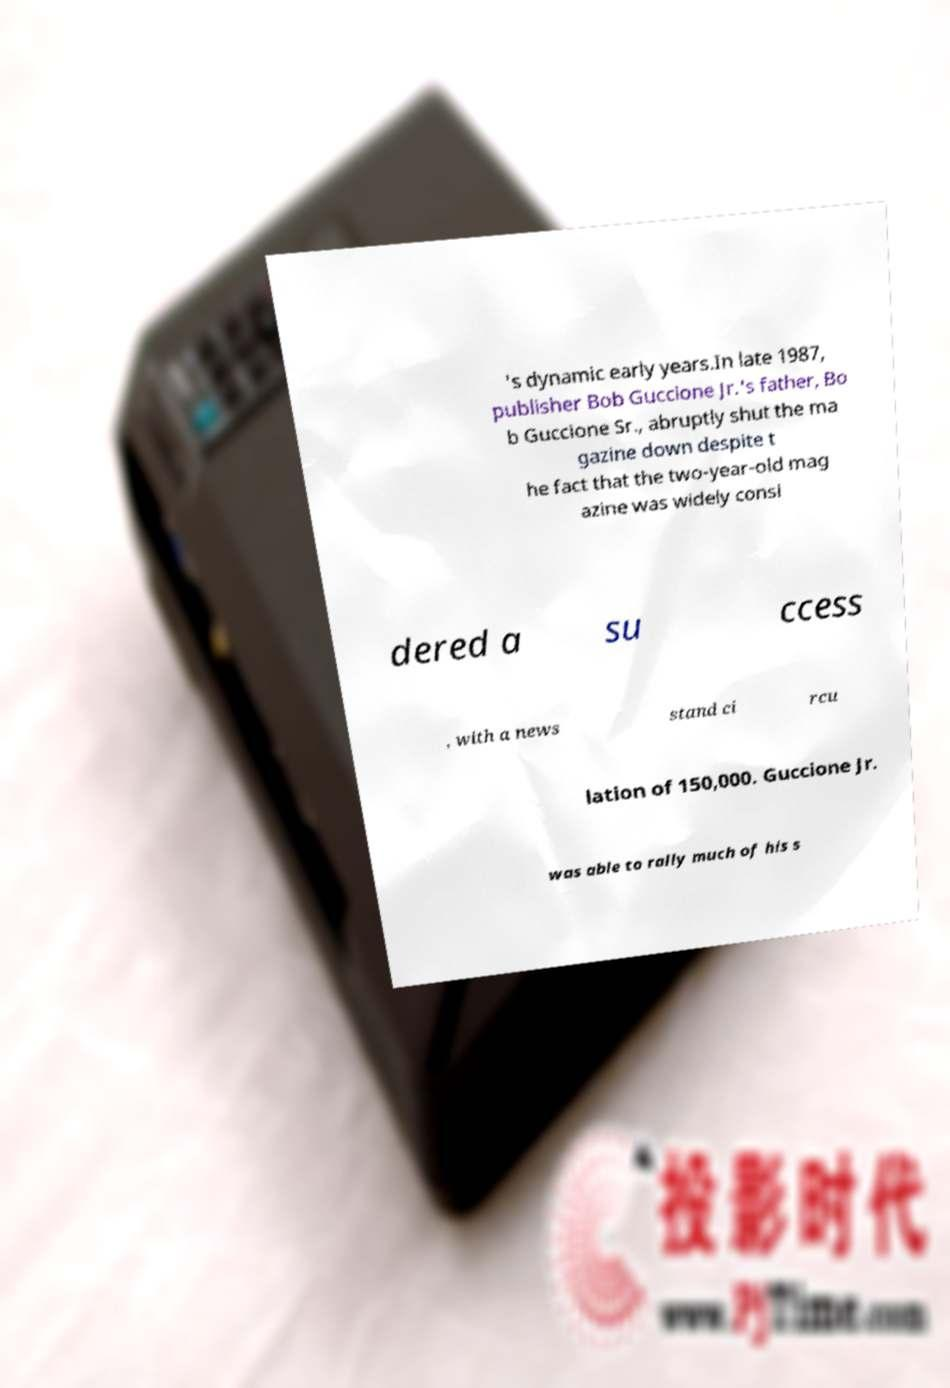Please read and relay the text visible in this image. What does it say? 's dynamic early years.In late 1987, publisher Bob Guccione Jr.'s father, Bo b Guccione Sr., abruptly shut the ma gazine down despite t he fact that the two-year-old mag azine was widely consi dered a su ccess , with a news stand ci rcu lation of 150,000. Guccione Jr. was able to rally much of his s 